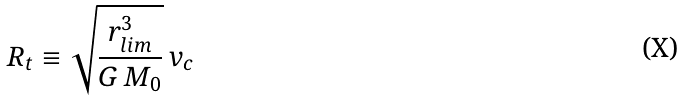<formula> <loc_0><loc_0><loc_500><loc_500>R _ { t } \equiv \sqrt { \frac { r _ { l i m } ^ { 3 } } { G \, M _ { 0 } } } \, v _ { c }</formula> 